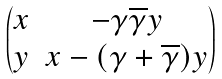<formula> <loc_0><loc_0><loc_500><loc_500>\begin{pmatrix} x & - \gamma \overline { \gamma } y \\ y & x - ( \gamma + \overline { \gamma } ) y \end{pmatrix}</formula> 